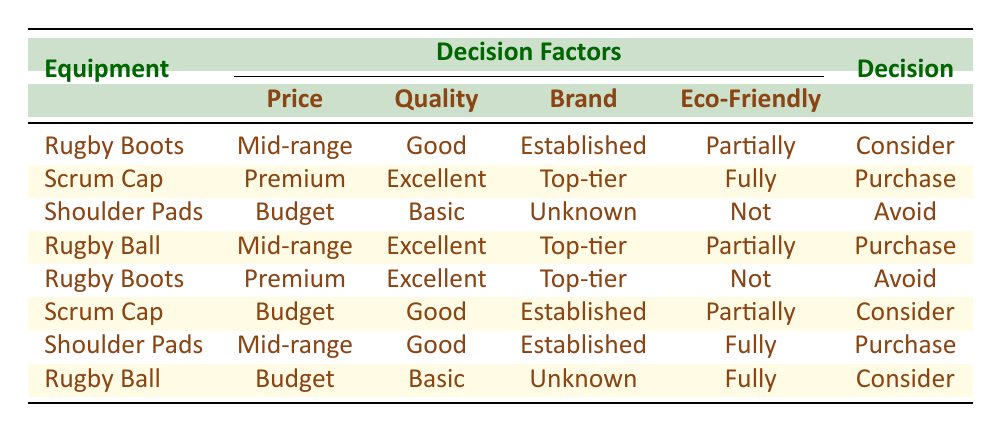What type of decision is made for "Rugby Boots" priced in the mid-range? According to the table, the decision for "Rugby Boots" in the mid-range pricing (between $50 and $150) is "Consider."
Answer: Consider Which equipment has an "Avoid" decision due to being "Not eco-friendly"? The "Shoulder Pads," which are budget-priced and of basic quality, have the decision to "Avoid" because they are classified as "Not eco-friendly."
Answer: Shoulder Pads Among all the equipment, which one is recommended to "Purchase" based on being "Fully eco-friendly"? The "Scrum Cap" priced at a premium and of excellent quality is recommended to "Purchase" as it is "Fully eco-friendly."
Answer: Scrum Cap How many types of equipment have a decision to "Consider"? There are three pieces of equipment with the decision "Consider": "Rugby Boots" (mid-range, good quality), "Scrum Cap" (budget, good quality), and "Rugby Ball" (budget, basic quality).
Answer: 3 Is it true that every "Premium" priced equipment has an "Avoid" decision? This is false. The "Scrum Cap" priced at a premium and of excellent quality has a "Purchase" decision, while the other premium equipment also has an "Avoid" decision.
Answer: No What is the average quality level of items that are suggested to "Purchase"? The quality levels of items recommended for purchase are "Excellent" for the "Scrum Cap" and "Rugby Ball," and "Good" for the "Shoulder Pads." This averages to (2 + 3 + 2)/3 = 2.33. Considering the coded values: Basic = 1, Good = 2, Excellent = 3, the average quality level is approximately 2.33.
Answer: Approximately 2.33 Which equipment is both "Good" in quality and "Partially eco-friendly" with a decision to "Consider"? "Rugby Boots" priced in the mid-range category are "Good" in quality and "Partially eco-friendly," resulting in a decision to "Consider."
Answer: Rugby Boots How does the quality of the "Shoulder Pads" in the budget range compare to that of the "Rugby Ball" in the mid-range? The "Shoulder Pads" are of "Basic" quality while the "Rugby Ball" in the mid-range is of "Excellent" quality. This shows that the Rugby Ball has a significantly higher quality rating than the Shoulder Pads.
Answer: Basic vs. Excellent 